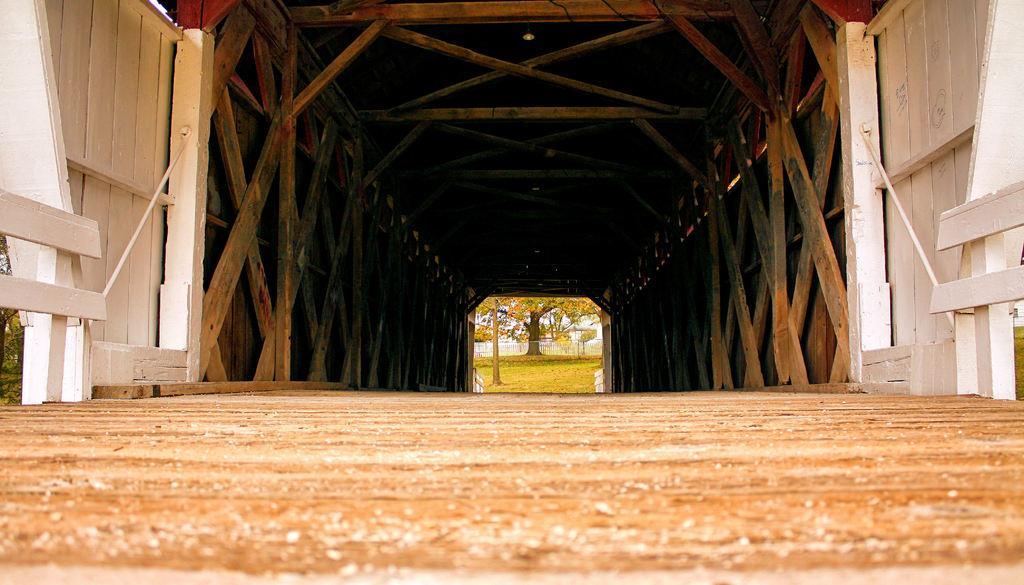Could you give a brief overview of what you see in this image? In this image we can see wooden bars, trees and ground. 